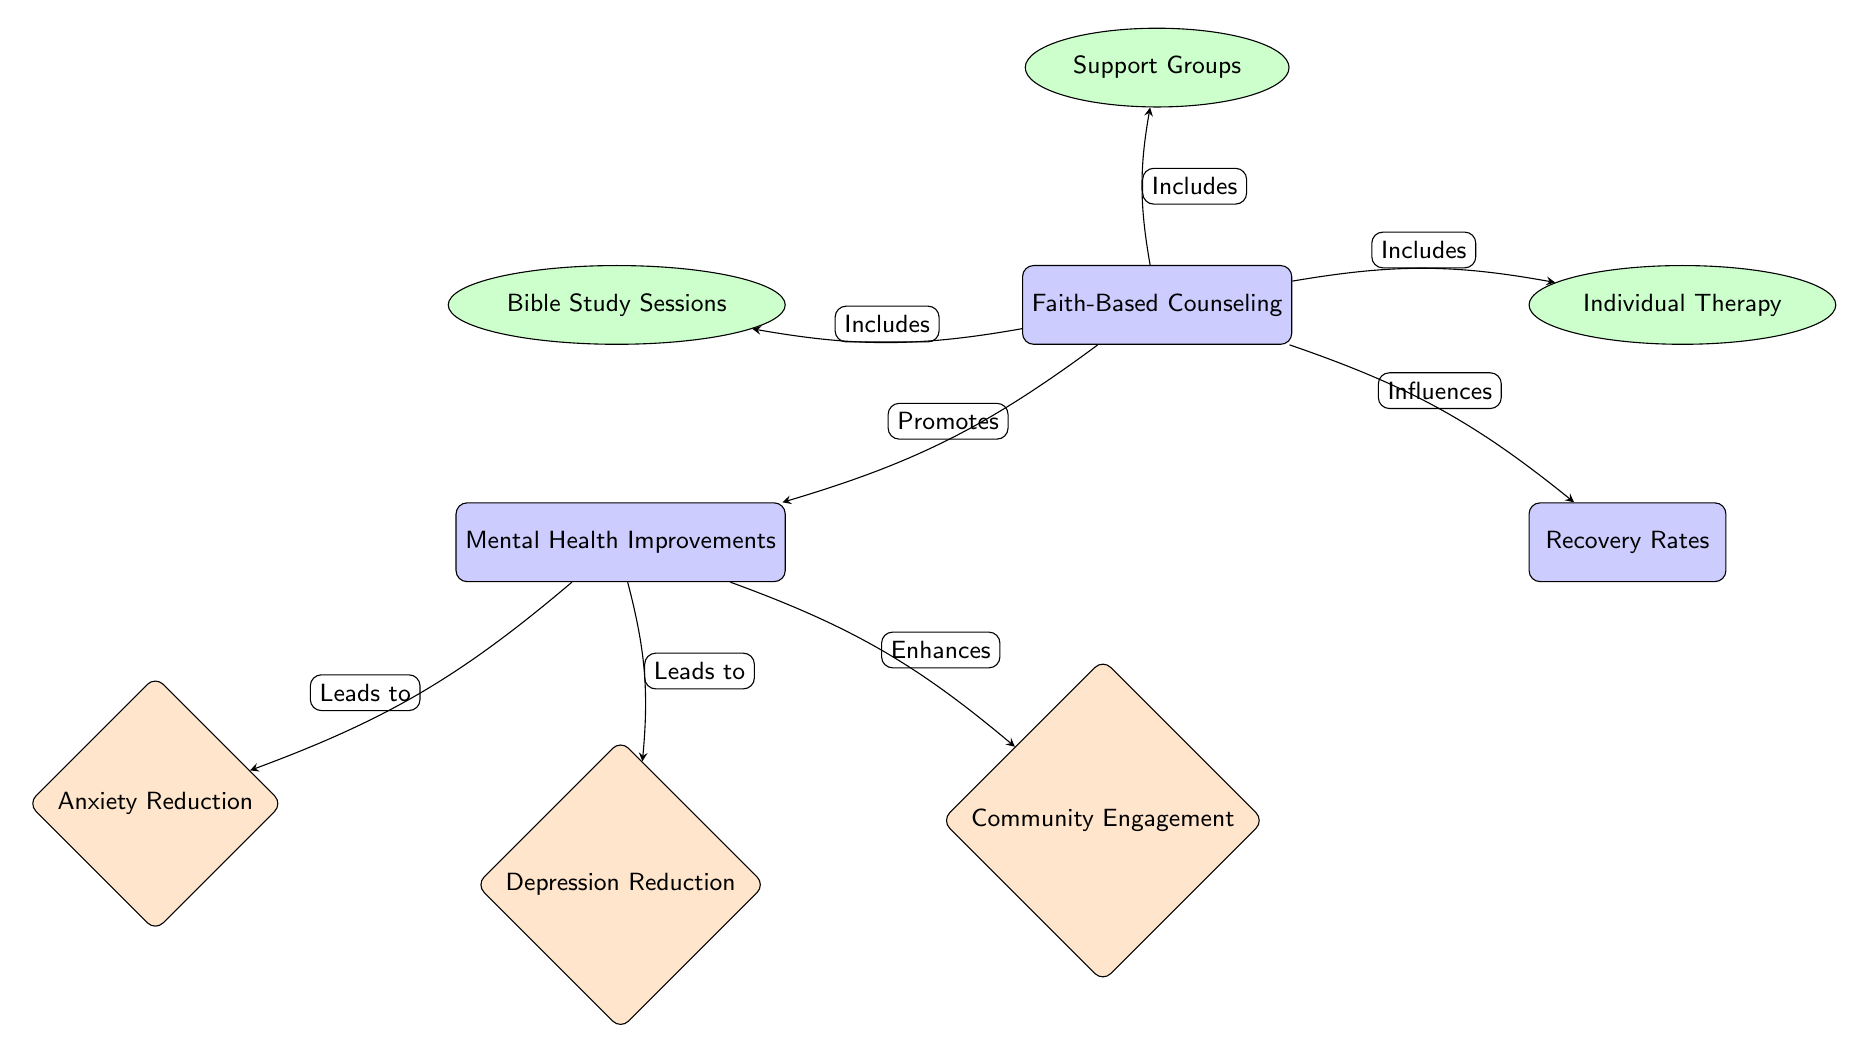What is the main focus of this diagram? The diagram centers around "Faith-Based Counseling," which is identified as the main node. This is the primary subject that the other components connect to, representing its central role in the relationships shown.
Answer: Faith-Based Counseling How many secondary nodes are present? There are three secondary nodes branching from the main node "Faith-Based Counseling." They represent different methods included in faith-based counseling: Bible Study Sessions, Support Groups, and Individual Therapy.
Answer: 3 Which node is influenced by "Faith-Based Counseling"? "Recovery Rates" is directly influenced by "Faith-Based Counseling," as indicated by the arrow labeled "Influences." This shows that the counseling approach affects recovery rates of individuals.
Answer: Recovery Rates What does "Mental Health Improvements" lead to? "Mental Health Improvements" lead to three separate outcomes: Anxiety Reduction, Depression Reduction, and Community Engagement. This is evidenced by the arrows showing the relationships leading from "Mental Health Improvements."
Answer: Anxiety Reduction, Depression Reduction, Community Engagement What type of node is "Individual Therapy"? "Individual Therapy" is categorized as a secondary node in the diagram. It is an ellipse and serves as one of the methods included under the overarching "Faith-Based Counseling."
Answer: Secondary How does "Mental Health Improvements" affect "Community Engagement"? "Mental Health Improvements" enhances "Community Engagement" as indicated by the arrow labeled "Enhances." This signifies a direct connection where improvements in mental health contribute positively to community involvement.
Answer: Enhances Which edge shows a relation that includes "Bible Study Sessions"? The edge from "Faith-Based Counseling" to "Bible Study Sessions" indicates that bible study sessions are included as part of the faith-based counseling framework. This connection is marked by the arrow labeled "Includes."
Answer: Includes What is the relationship between "Mental Health Improvements" and "Anxiety Reduction"? The relationship is that "Mental Health Improvements" leads to "Anxiety Reduction." This means that as mental health improves, there is a direct positive effect leading to a reduction in anxiety levels.
Answer: Leads to 